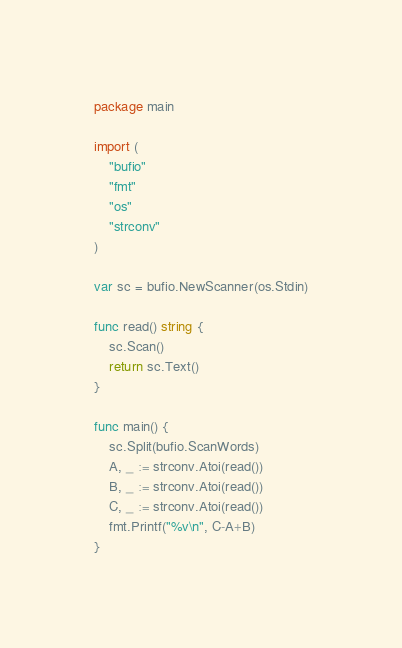Convert code to text. <code><loc_0><loc_0><loc_500><loc_500><_Go_>package main

import (
	"bufio"
	"fmt"
	"os"
	"strconv"
)

var sc = bufio.NewScanner(os.Stdin)

func read() string {
	sc.Scan()
	return sc.Text()
}

func main() {
	sc.Split(bufio.ScanWords)
	A, _ := strconv.Atoi(read())
	B, _ := strconv.Atoi(read())
	C, _ := strconv.Atoi(read())
	fmt.Printf("%v\n", C-A+B)
}
</code> 